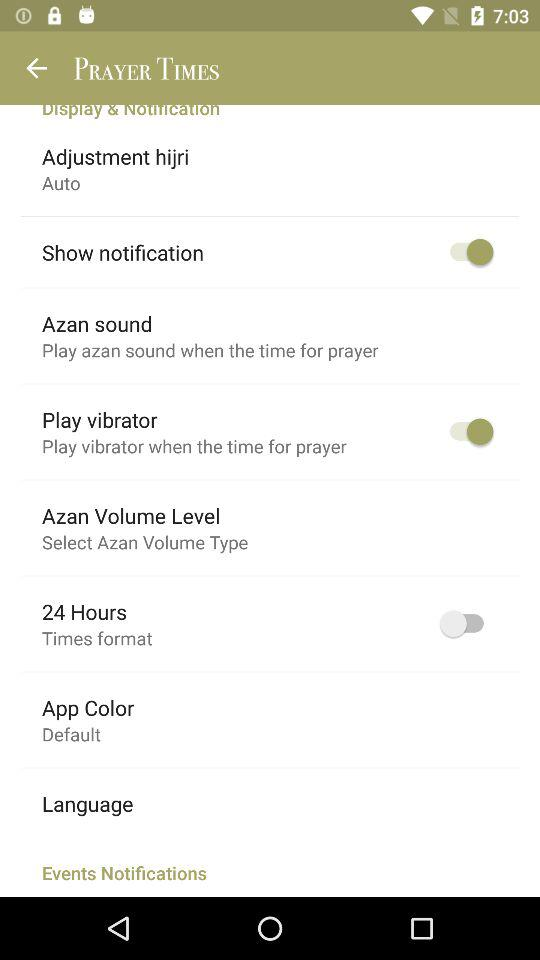What's the setting for the play vibrator? The setting for the play vibrator is "on". 